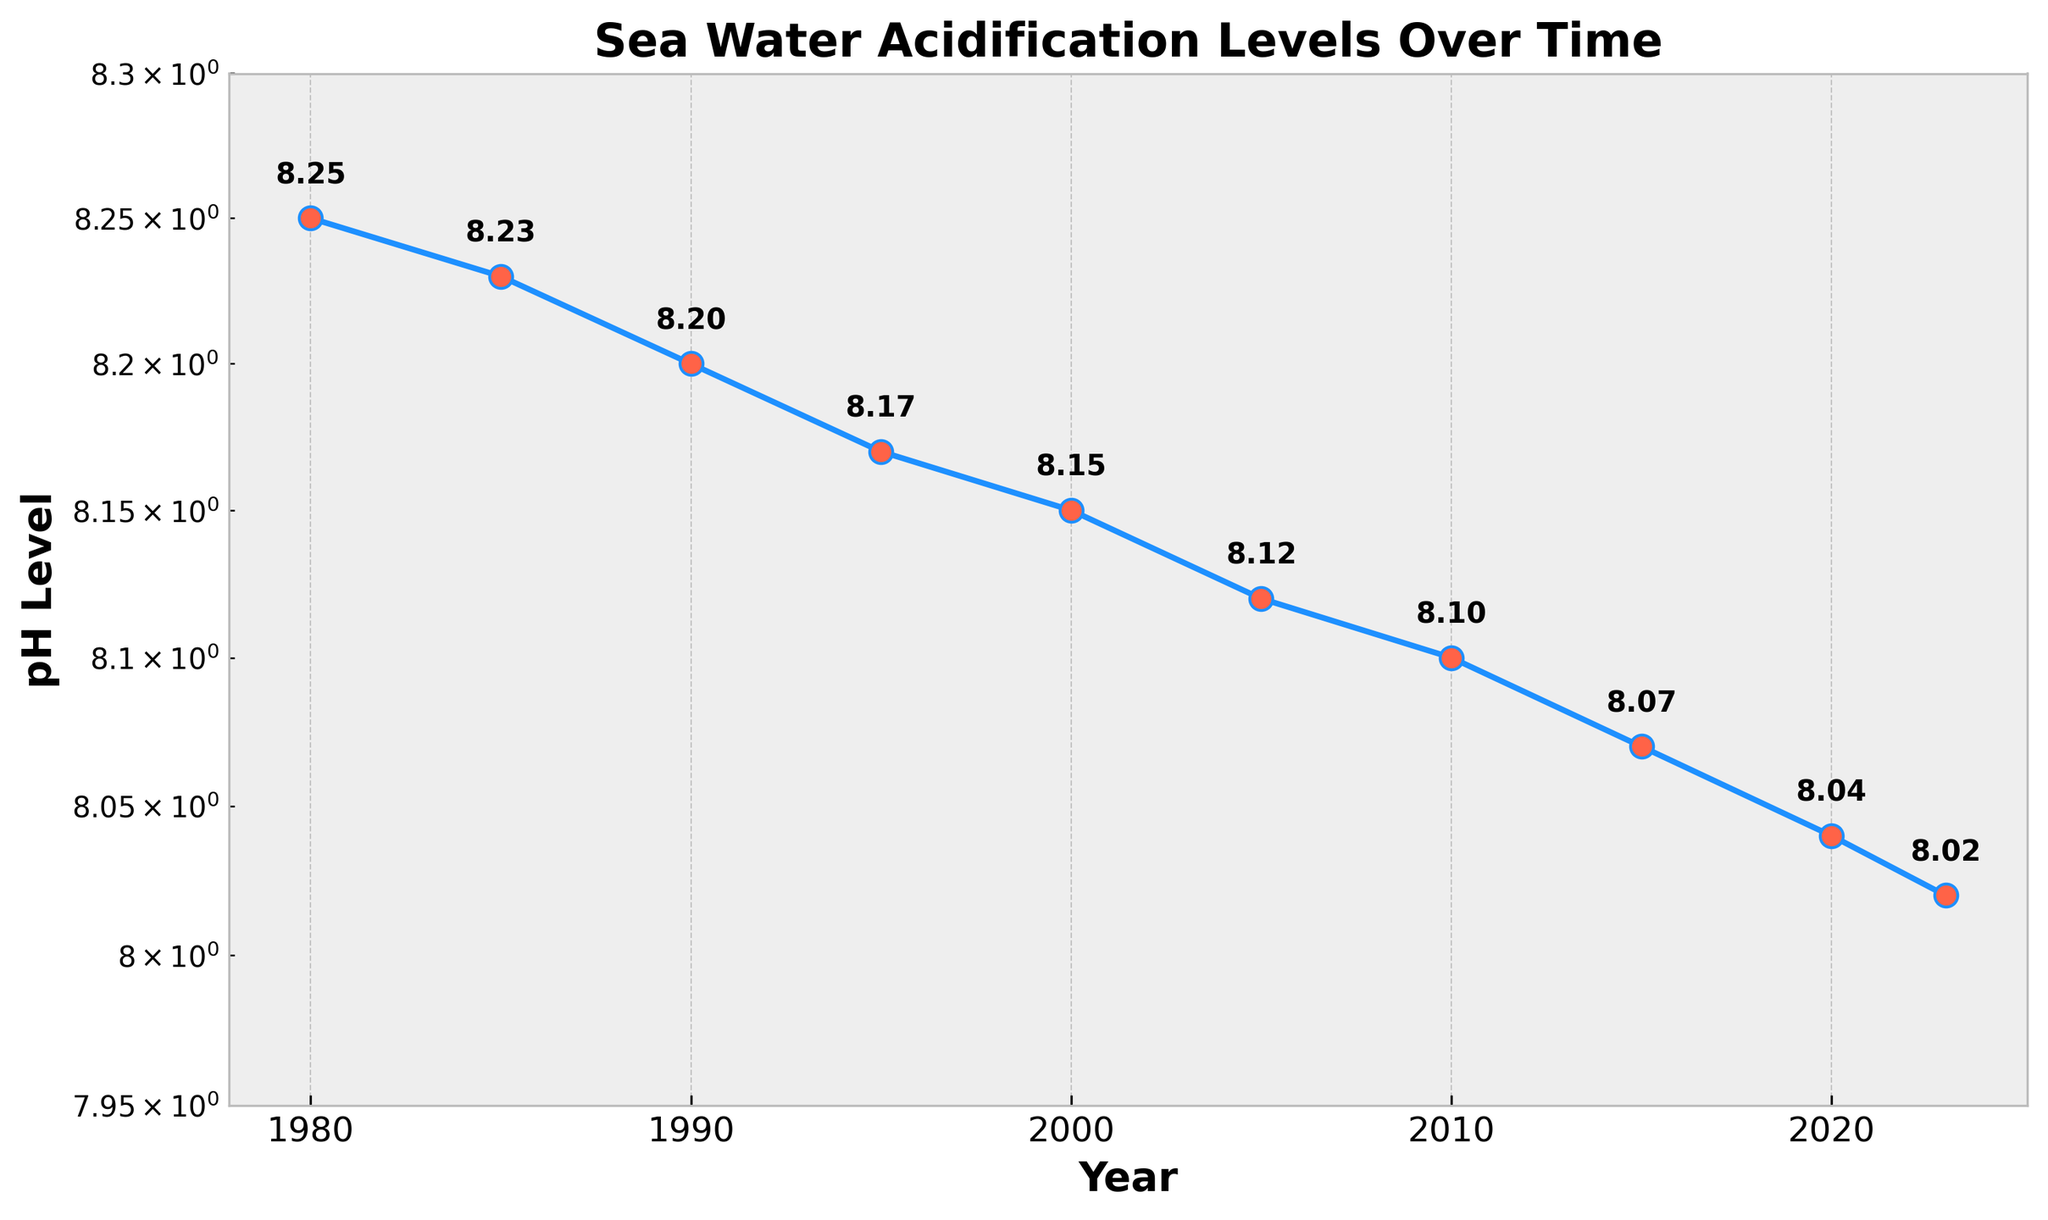What is the title of the figure? The title is typically placed at the top of the figure and is written in larger, bold text to easily catch the viewer's attention.
Answer: Sea Water Acidification Levels Over Time How many data points are plotted in the figure? Each data point can be identified by the markers on the plot. Count the number of markers to determine the total number of data points.
Answer: 10 What is the pH level in the year 2000? Locate the year 2000 on the x-axis and trace vertically to the corresponding pH level on the y-axis. The annotated value next to the marker will provide the exact pH level.
Answer: 8.15 How does the pH level change from 1980 to 2023? Identify the pH levels in 1980 and 2023, then find the difference by subtracting the 2023 value from the 1980 value.
Answer: The pH level decreases from 8.25 to 8.02 Which year experienced the steepest decrease in pH level? Examine the plot to identify the segment with the steepest downward slope. This segment corresponds to the steepest change in pH level over time.
Answer: Between 2010 and 2015 Is the pH level trend increasing or decreasing over time? Observe the overall direction of the plotted line from left to right. If it moves downward, the trend is decreasing; if upward, it is increasing.
Answer: Decreasing What is the difference in pH level between the years 1990 and 2010? Locate the pH levels for 1990 (8.20) and 2010 (8.10). Subtract the 2010 value from the 1990 value to find the difference.
Answer: 0.10 What is the average pH level from 1980 to 2023? Sum all the pH values given for each year and then divide by the total number of years (10) to find the average.
Answer: (8.25 + 8.23 + 8.20 + 8.17 + 8.15 + 8.12 + 8.10 + 8.07 + 8.04 + 8.02) / 10 = 8.135 Which year had a pH level closest to 8.10? Identify the year(s) with a pH level close to 8.10 by comparing the given pH values and determining the closest match.
Answer: 2010 How many years did it take for the pH level to drop from approximately 8.20 to 8.10? Determine the years in which the pH levels were 8.20 (1990) and 8.10 (2010). Subtract the earlier year from the later year to find the number of years it took.
Answer: 2010 - 1990 = 20 years 